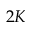Convert formula to latex. <formula><loc_0><loc_0><loc_500><loc_500>2 K</formula> 